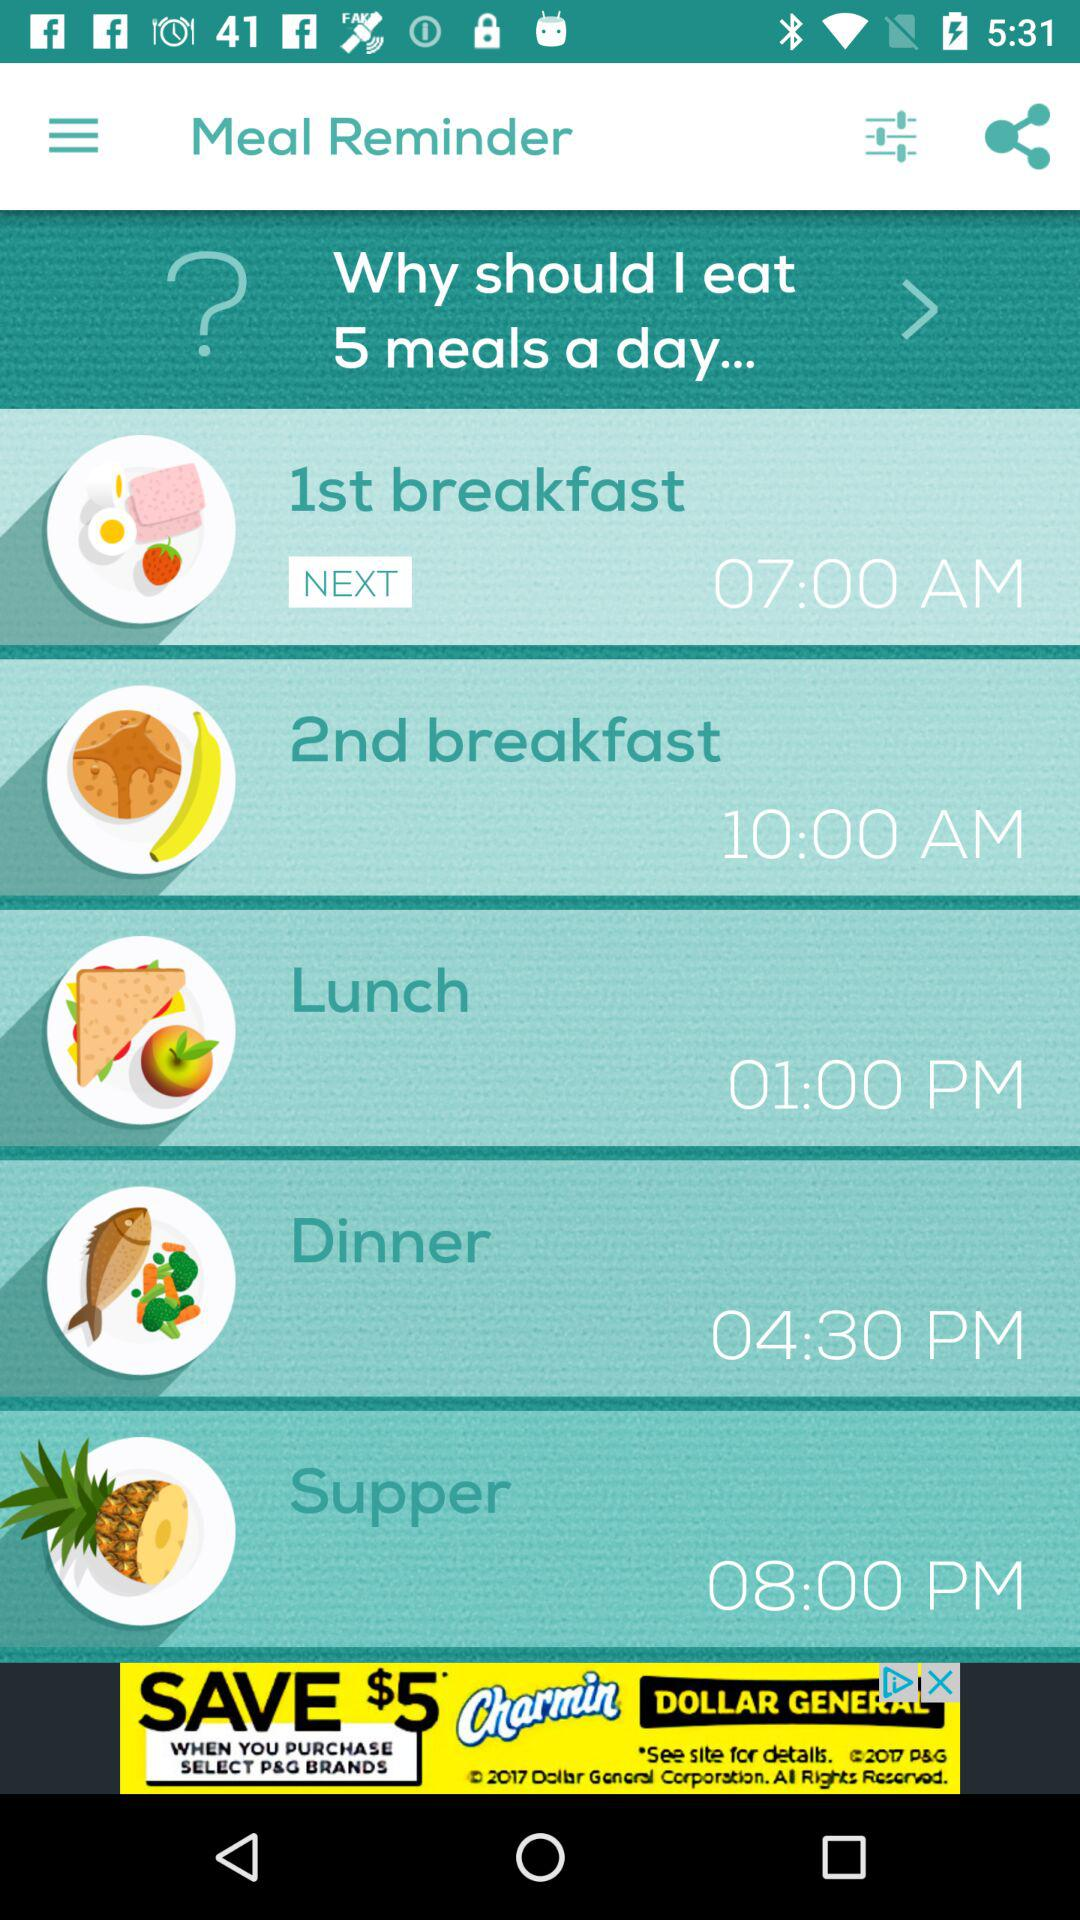Based on the image, what kind of foods does the app suggest for each meal? The app suggests a variety of foods for balanced nutrition: fruit and toast for the 1st breakfast, a banana for the 2nd breakfast, a sandwich and apple for lunch, a fish dish with vegetables for dinner, and pineapple for supper. 